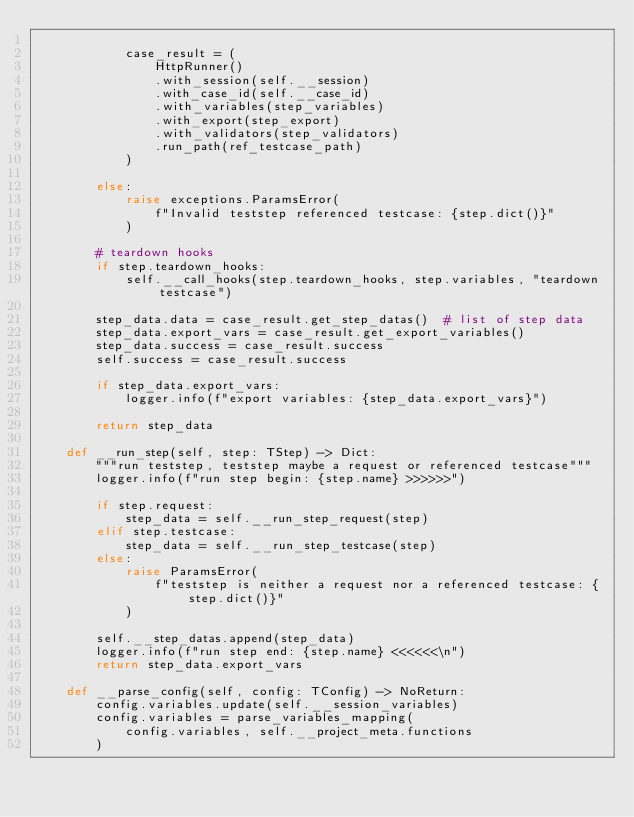<code> <loc_0><loc_0><loc_500><loc_500><_Python_>
            case_result = (
                HttpRunner()
                .with_session(self.__session)
                .with_case_id(self.__case_id)
                .with_variables(step_variables)
                .with_export(step_export)
                .with_validators(step_validators)
                .run_path(ref_testcase_path)
            )

        else:
            raise exceptions.ParamsError(
                f"Invalid teststep referenced testcase: {step.dict()}"
            )

        # teardown hooks
        if step.teardown_hooks:
            self.__call_hooks(step.teardown_hooks, step.variables, "teardown testcase")

        step_data.data = case_result.get_step_datas()  # list of step data
        step_data.export_vars = case_result.get_export_variables()
        step_data.success = case_result.success
        self.success = case_result.success

        if step_data.export_vars:
            logger.info(f"export variables: {step_data.export_vars}")

        return step_data

    def __run_step(self, step: TStep) -> Dict:
        """run teststep, teststep maybe a request or referenced testcase"""
        logger.info(f"run step begin: {step.name} >>>>>>")

        if step.request:
            step_data = self.__run_step_request(step)
        elif step.testcase:
            step_data = self.__run_step_testcase(step)
        else:
            raise ParamsError(
                f"teststep is neither a request nor a referenced testcase: {step.dict()}"
            )

        self.__step_datas.append(step_data)
        logger.info(f"run step end: {step.name} <<<<<<\n")
        return step_data.export_vars

    def __parse_config(self, config: TConfig) -> NoReturn:
        config.variables.update(self.__session_variables)
        config.variables = parse_variables_mapping(
            config.variables, self.__project_meta.functions
        )</code> 